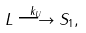<formula> <loc_0><loc_0><loc_500><loc_500>L \overset { k _ { U } } { \longrightarrow } S _ { 1 } ,</formula> 